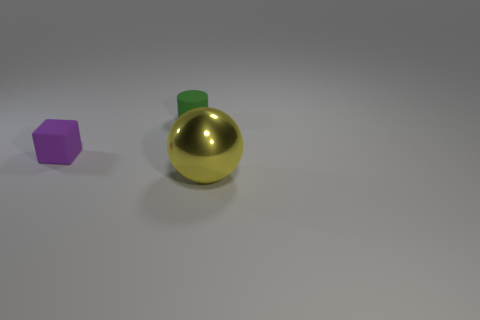What number of objects are small rubber things to the right of the tiny purple thing or small things that are to the right of the small purple block?
Give a very brief answer. 1. The thing that is to the right of the tiny green object has what shape?
Make the answer very short. Sphere. Does the matte thing that is to the right of the purple matte cube have the same shape as the tiny purple rubber object?
Offer a terse response. No. What number of objects are either things behind the large yellow metal sphere or big yellow shiny things?
Make the answer very short. 3. Is there any other thing of the same color as the large metallic thing?
Provide a succinct answer. No. What size is the metal thing that is right of the small green object?
Your answer should be very brief. Large. Do the large object and the matte object that is left of the green object have the same color?
Your answer should be very brief. No. What number of other objects are there of the same material as the sphere?
Offer a terse response. 0. Are there more tiny blocks than small metal spheres?
Your answer should be compact. Yes. There is a small thing that is behind the small purple block; is it the same color as the big shiny object?
Your response must be concise. No. 